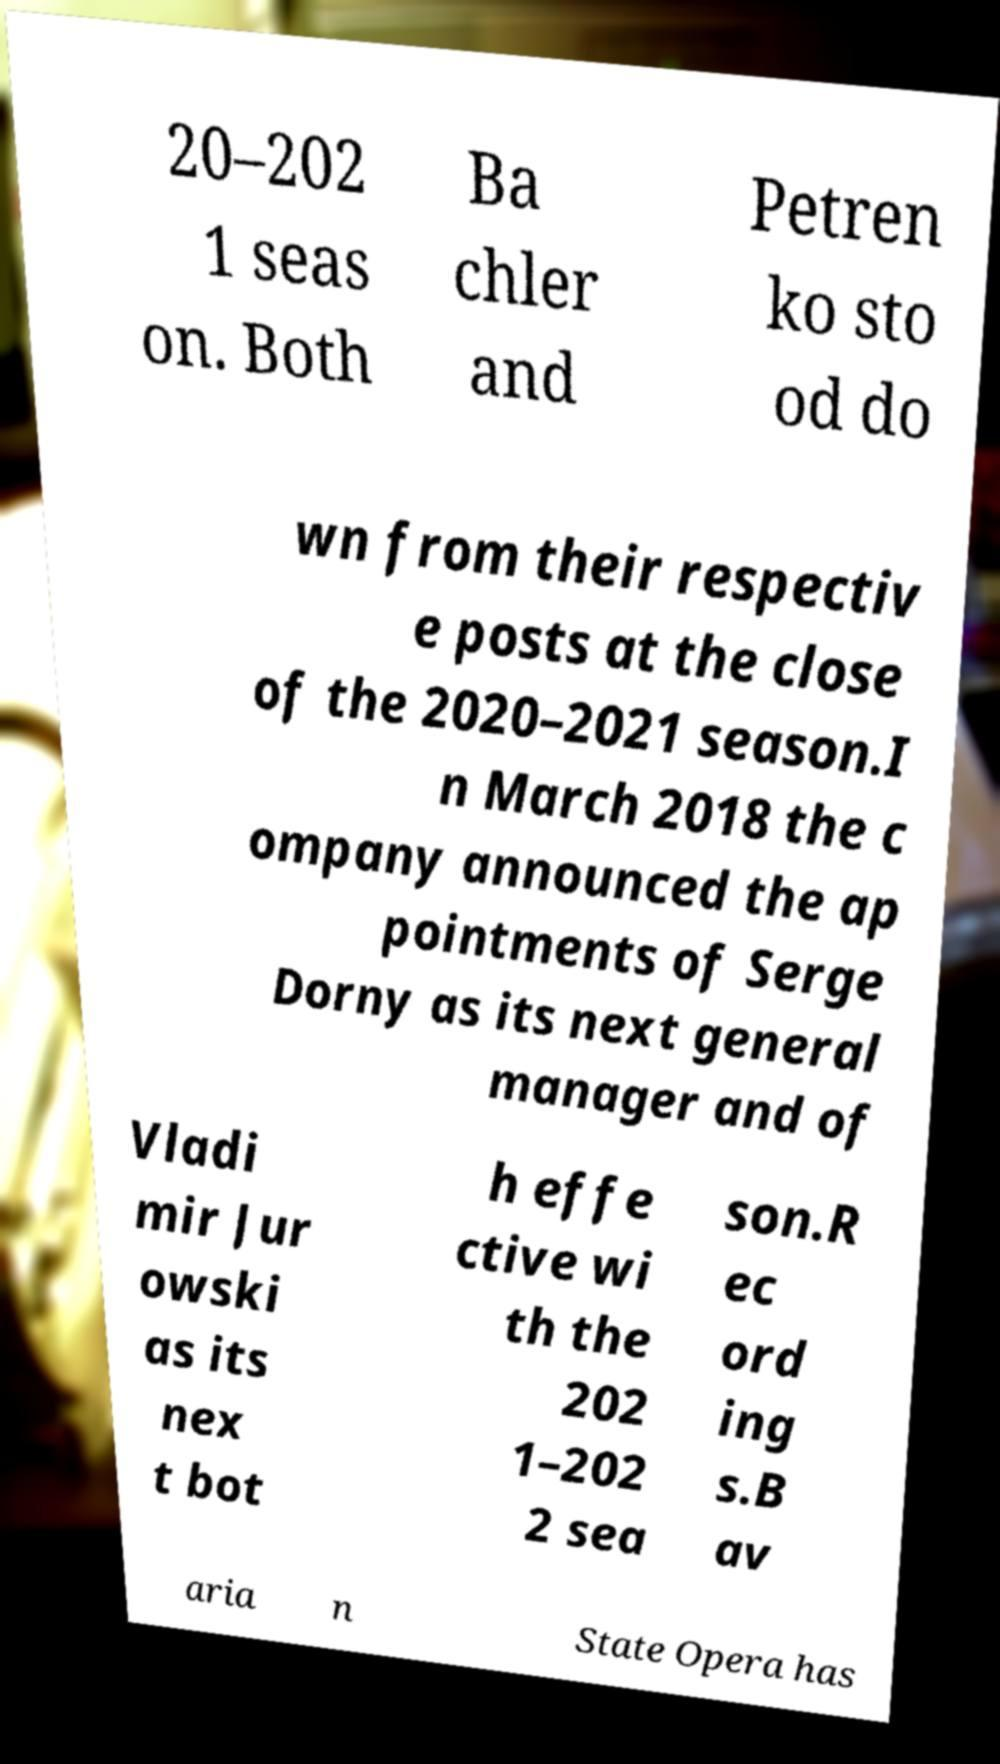Please read and relay the text visible in this image. What does it say? 20–202 1 seas on. Both Ba chler and Petren ko sto od do wn from their respectiv e posts at the close of the 2020–2021 season.I n March 2018 the c ompany announced the ap pointments of Serge Dorny as its next general manager and of Vladi mir Jur owski as its nex t bot h effe ctive wi th the 202 1–202 2 sea son.R ec ord ing s.B av aria n State Opera has 